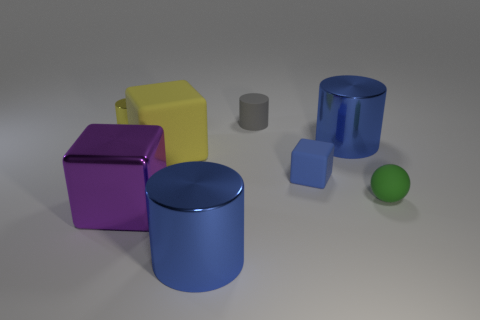There is a blue object that is the same size as the green ball; what material is it? The blue object that appears to be the same size as the green ball is most likely made of a hard, reflective material such as plastic or polished metal, indicated by its shiny surface and sharp reflections. 